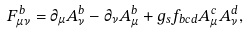Convert formula to latex. <formula><loc_0><loc_0><loc_500><loc_500>F _ { \mu \nu } ^ { b } = \partial _ { \mu } A _ { \nu } ^ { b } - \partial _ { \nu } A _ { \mu } ^ { b } + g _ { s } f _ { b c d } A _ { \mu } ^ { c } A _ { \nu } ^ { d } ,</formula> 